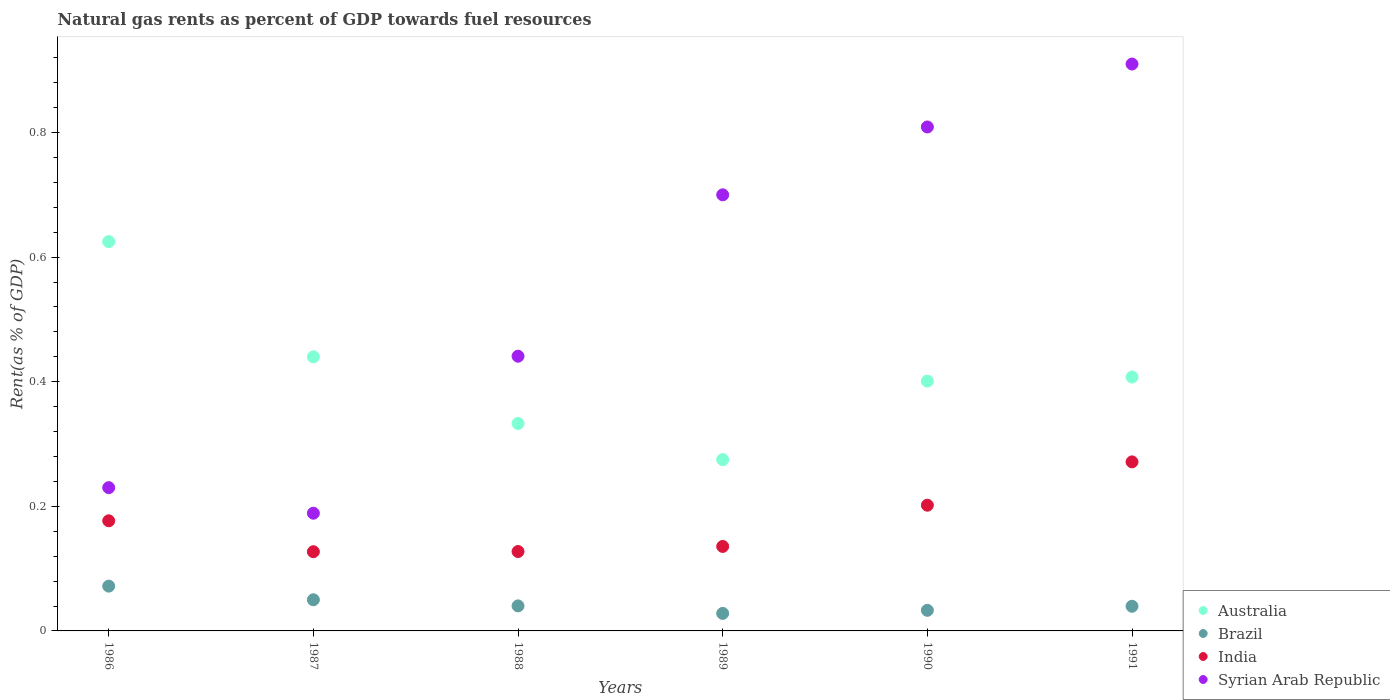Is the number of dotlines equal to the number of legend labels?
Make the answer very short. Yes. What is the matural gas rent in Syrian Arab Republic in 1990?
Your answer should be compact. 0.81. Across all years, what is the maximum matural gas rent in India?
Make the answer very short. 0.27. Across all years, what is the minimum matural gas rent in Brazil?
Your response must be concise. 0.03. In which year was the matural gas rent in Syrian Arab Republic maximum?
Your answer should be compact. 1991. In which year was the matural gas rent in Syrian Arab Republic minimum?
Ensure brevity in your answer.  1987. What is the total matural gas rent in Australia in the graph?
Offer a terse response. 2.48. What is the difference between the matural gas rent in Syrian Arab Republic in 1987 and that in 1990?
Make the answer very short. -0.62. What is the difference between the matural gas rent in Australia in 1989 and the matural gas rent in Brazil in 1986?
Offer a terse response. 0.2. What is the average matural gas rent in Brazil per year?
Offer a terse response. 0.04. In the year 1986, what is the difference between the matural gas rent in India and matural gas rent in Brazil?
Provide a succinct answer. 0.1. In how many years, is the matural gas rent in Brazil greater than 0.04 %?
Provide a short and direct response. 3. What is the ratio of the matural gas rent in Australia in 1986 to that in 1987?
Your answer should be compact. 1.42. Is the difference between the matural gas rent in India in 1987 and 1988 greater than the difference between the matural gas rent in Brazil in 1987 and 1988?
Keep it short and to the point. No. What is the difference between the highest and the second highest matural gas rent in India?
Offer a very short reply. 0.07. What is the difference between the highest and the lowest matural gas rent in Syrian Arab Republic?
Make the answer very short. 0.72. In how many years, is the matural gas rent in India greater than the average matural gas rent in India taken over all years?
Your answer should be compact. 3. How many dotlines are there?
Ensure brevity in your answer.  4. What is the difference between two consecutive major ticks on the Y-axis?
Offer a terse response. 0.2. Does the graph contain any zero values?
Your answer should be very brief. No. What is the title of the graph?
Your answer should be very brief. Natural gas rents as percent of GDP towards fuel resources. Does "Tuvalu" appear as one of the legend labels in the graph?
Make the answer very short. No. What is the label or title of the X-axis?
Your answer should be compact. Years. What is the label or title of the Y-axis?
Your answer should be very brief. Rent(as % of GDP). What is the Rent(as % of GDP) in Australia in 1986?
Your answer should be very brief. 0.62. What is the Rent(as % of GDP) of Brazil in 1986?
Offer a very short reply. 0.07. What is the Rent(as % of GDP) of India in 1986?
Your answer should be compact. 0.18. What is the Rent(as % of GDP) in Syrian Arab Republic in 1986?
Provide a succinct answer. 0.23. What is the Rent(as % of GDP) in Australia in 1987?
Ensure brevity in your answer.  0.44. What is the Rent(as % of GDP) of Brazil in 1987?
Make the answer very short. 0.05. What is the Rent(as % of GDP) of India in 1987?
Your response must be concise. 0.13. What is the Rent(as % of GDP) of Syrian Arab Republic in 1987?
Provide a short and direct response. 0.19. What is the Rent(as % of GDP) of Australia in 1988?
Provide a succinct answer. 0.33. What is the Rent(as % of GDP) of Brazil in 1988?
Offer a very short reply. 0.04. What is the Rent(as % of GDP) of India in 1988?
Ensure brevity in your answer.  0.13. What is the Rent(as % of GDP) of Syrian Arab Republic in 1988?
Offer a very short reply. 0.44. What is the Rent(as % of GDP) in Australia in 1989?
Provide a short and direct response. 0.27. What is the Rent(as % of GDP) in Brazil in 1989?
Your response must be concise. 0.03. What is the Rent(as % of GDP) of India in 1989?
Keep it short and to the point. 0.14. What is the Rent(as % of GDP) in Syrian Arab Republic in 1989?
Your answer should be very brief. 0.7. What is the Rent(as % of GDP) of Australia in 1990?
Offer a very short reply. 0.4. What is the Rent(as % of GDP) of Brazil in 1990?
Keep it short and to the point. 0.03. What is the Rent(as % of GDP) in India in 1990?
Keep it short and to the point. 0.2. What is the Rent(as % of GDP) in Syrian Arab Republic in 1990?
Give a very brief answer. 0.81. What is the Rent(as % of GDP) of Australia in 1991?
Offer a very short reply. 0.41. What is the Rent(as % of GDP) of Brazil in 1991?
Keep it short and to the point. 0.04. What is the Rent(as % of GDP) of India in 1991?
Keep it short and to the point. 0.27. What is the Rent(as % of GDP) in Syrian Arab Republic in 1991?
Offer a terse response. 0.91. Across all years, what is the maximum Rent(as % of GDP) of Australia?
Give a very brief answer. 0.62. Across all years, what is the maximum Rent(as % of GDP) of Brazil?
Your answer should be compact. 0.07. Across all years, what is the maximum Rent(as % of GDP) in India?
Give a very brief answer. 0.27. Across all years, what is the maximum Rent(as % of GDP) in Syrian Arab Republic?
Offer a very short reply. 0.91. Across all years, what is the minimum Rent(as % of GDP) in Australia?
Your answer should be compact. 0.27. Across all years, what is the minimum Rent(as % of GDP) in Brazil?
Give a very brief answer. 0.03. Across all years, what is the minimum Rent(as % of GDP) of India?
Your response must be concise. 0.13. Across all years, what is the minimum Rent(as % of GDP) of Syrian Arab Republic?
Your answer should be compact. 0.19. What is the total Rent(as % of GDP) in Australia in the graph?
Provide a succinct answer. 2.48. What is the total Rent(as % of GDP) in Brazil in the graph?
Provide a short and direct response. 0.26. What is the total Rent(as % of GDP) in India in the graph?
Ensure brevity in your answer.  1.04. What is the total Rent(as % of GDP) of Syrian Arab Republic in the graph?
Provide a short and direct response. 3.28. What is the difference between the Rent(as % of GDP) in Australia in 1986 and that in 1987?
Offer a very short reply. 0.18. What is the difference between the Rent(as % of GDP) in Brazil in 1986 and that in 1987?
Keep it short and to the point. 0.02. What is the difference between the Rent(as % of GDP) in India in 1986 and that in 1987?
Offer a very short reply. 0.05. What is the difference between the Rent(as % of GDP) in Syrian Arab Republic in 1986 and that in 1987?
Make the answer very short. 0.04. What is the difference between the Rent(as % of GDP) in Australia in 1986 and that in 1988?
Provide a succinct answer. 0.29. What is the difference between the Rent(as % of GDP) of Brazil in 1986 and that in 1988?
Your response must be concise. 0.03. What is the difference between the Rent(as % of GDP) in India in 1986 and that in 1988?
Provide a succinct answer. 0.05. What is the difference between the Rent(as % of GDP) in Syrian Arab Republic in 1986 and that in 1988?
Provide a succinct answer. -0.21. What is the difference between the Rent(as % of GDP) of Brazil in 1986 and that in 1989?
Give a very brief answer. 0.04. What is the difference between the Rent(as % of GDP) of India in 1986 and that in 1989?
Make the answer very short. 0.04. What is the difference between the Rent(as % of GDP) of Syrian Arab Republic in 1986 and that in 1989?
Offer a terse response. -0.47. What is the difference between the Rent(as % of GDP) of Australia in 1986 and that in 1990?
Give a very brief answer. 0.22. What is the difference between the Rent(as % of GDP) in Brazil in 1986 and that in 1990?
Offer a terse response. 0.04. What is the difference between the Rent(as % of GDP) of India in 1986 and that in 1990?
Provide a succinct answer. -0.03. What is the difference between the Rent(as % of GDP) of Syrian Arab Republic in 1986 and that in 1990?
Offer a very short reply. -0.58. What is the difference between the Rent(as % of GDP) in Australia in 1986 and that in 1991?
Provide a succinct answer. 0.22. What is the difference between the Rent(as % of GDP) of Brazil in 1986 and that in 1991?
Your response must be concise. 0.03. What is the difference between the Rent(as % of GDP) in India in 1986 and that in 1991?
Your answer should be compact. -0.09. What is the difference between the Rent(as % of GDP) of Syrian Arab Republic in 1986 and that in 1991?
Offer a terse response. -0.68. What is the difference between the Rent(as % of GDP) of Australia in 1987 and that in 1988?
Provide a succinct answer. 0.11. What is the difference between the Rent(as % of GDP) in Brazil in 1987 and that in 1988?
Make the answer very short. 0.01. What is the difference between the Rent(as % of GDP) of India in 1987 and that in 1988?
Provide a short and direct response. -0. What is the difference between the Rent(as % of GDP) in Syrian Arab Republic in 1987 and that in 1988?
Give a very brief answer. -0.25. What is the difference between the Rent(as % of GDP) in Australia in 1987 and that in 1989?
Your answer should be very brief. 0.17. What is the difference between the Rent(as % of GDP) of Brazil in 1987 and that in 1989?
Offer a very short reply. 0.02. What is the difference between the Rent(as % of GDP) in India in 1987 and that in 1989?
Keep it short and to the point. -0.01. What is the difference between the Rent(as % of GDP) of Syrian Arab Republic in 1987 and that in 1989?
Provide a succinct answer. -0.51. What is the difference between the Rent(as % of GDP) of Australia in 1987 and that in 1990?
Your answer should be very brief. 0.04. What is the difference between the Rent(as % of GDP) of Brazil in 1987 and that in 1990?
Offer a very short reply. 0.02. What is the difference between the Rent(as % of GDP) of India in 1987 and that in 1990?
Your answer should be compact. -0.07. What is the difference between the Rent(as % of GDP) in Syrian Arab Republic in 1987 and that in 1990?
Offer a very short reply. -0.62. What is the difference between the Rent(as % of GDP) in Australia in 1987 and that in 1991?
Your answer should be very brief. 0.03. What is the difference between the Rent(as % of GDP) in Brazil in 1987 and that in 1991?
Ensure brevity in your answer.  0.01. What is the difference between the Rent(as % of GDP) in India in 1987 and that in 1991?
Ensure brevity in your answer.  -0.14. What is the difference between the Rent(as % of GDP) in Syrian Arab Republic in 1987 and that in 1991?
Offer a very short reply. -0.72. What is the difference between the Rent(as % of GDP) in Australia in 1988 and that in 1989?
Make the answer very short. 0.06. What is the difference between the Rent(as % of GDP) of Brazil in 1988 and that in 1989?
Your answer should be compact. 0.01. What is the difference between the Rent(as % of GDP) in India in 1988 and that in 1989?
Ensure brevity in your answer.  -0.01. What is the difference between the Rent(as % of GDP) of Syrian Arab Republic in 1988 and that in 1989?
Your response must be concise. -0.26. What is the difference between the Rent(as % of GDP) in Australia in 1988 and that in 1990?
Ensure brevity in your answer.  -0.07. What is the difference between the Rent(as % of GDP) in Brazil in 1988 and that in 1990?
Offer a very short reply. 0.01. What is the difference between the Rent(as % of GDP) in India in 1988 and that in 1990?
Give a very brief answer. -0.07. What is the difference between the Rent(as % of GDP) in Syrian Arab Republic in 1988 and that in 1990?
Make the answer very short. -0.37. What is the difference between the Rent(as % of GDP) of Australia in 1988 and that in 1991?
Keep it short and to the point. -0.07. What is the difference between the Rent(as % of GDP) in Brazil in 1988 and that in 1991?
Offer a terse response. 0. What is the difference between the Rent(as % of GDP) in India in 1988 and that in 1991?
Offer a very short reply. -0.14. What is the difference between the Rent(as % of GDP) of Syrian Arab Republic in 1988 and that in 1991?
Offer a terse response. -0.47. What is the difference between the Rent(as % of GDP) of Australia in 1989 and that in 1990?
Keep it short and to the point. -0.13. What is the difference between the Rent(as % of GDP) in Brazil in 1989 and that in 1990?
Your answer should be compact. -0.01. What is the difference between the Rent(as % of GDP) in India in 1989 and that in 1990?
Ensure brevity in your answer.  -0.07. What is the difference between the Rent(as % of GDP) of Syrian Arab Republic in 1989 and that in 1990?
Keep it short and to the point. -0.11. What is the difference between the Rent(as % of GDP) of Australia in 1989 and that in 1991?
Make the answer very short. -0.13. What is the difference between the Rent(as % of GDP) in Brazil in 1989 and that in 1991?
Make the answer very short. -0.01. What is the difference between the Rent(as % of GDP) of India in 1989 and that in 1991?
Provide a short and direct response. -0.14. What is the difference between the Rent(as % of GDP) of Syrian Arab Republic in 1989 and that in 1991?
Offer a terse response. -0.21. What is the difference between the Rent(as % of GDP) in Australia in 1990 and that in 1991?
Make the answer very short. -0.01. What is the difference between the Rent(as % of GDP) of Brazil in 1990 and that in 1991?
Your response must be concise. -0.01. What is the difference between the Rent(as % of GDP) in India in 1990 and that in 1991?
Your answer should be very brief. -0.07. What is the difference between the Rent(as % of GDP) of Syrian Arab Republic in 1990 and that in 1991?
Give a very brief answer. -0.1. What is the difference between the Rent(as % of GDP) of Australia in 1986 and the Rent(as % of GDP) of Brazil in 1987?
Your answer should be compact. 0.57. What is the difference between the Rent(as % of GDP) in Australia in 1986 and the Rent(as % of GDP) in India in 1987?
Keep it short and to the point. 0.5. What is the difference between the Rent(as % of GDP) of Australia in 1986 and the Rent(as % of GDP) of Syrian Arab Republic in 1987?
Your response must be concise. 0.44. What is the difference between the Rent(as % of GDP) in Brazil in 1986 and the Rent(as % of GDP) in India in 1987?
Your answer should be very brief. -0.06. What is the difference between the Rent(as % of GDP) in Brazil in 1986 and the Rent(as % of GDP) in Syrian Arab Republic in 1987?
Your answer should be compact. -0.12. What is the difference between the Rent(as % of GDP) in India in 1986 and the Rent(as % of GDP) in Syrian Arab Republic in 1987?
Make the answer very short. -0.01. What is the difference between the Rent(as % of GDP) of Australia in 1986 and the Rent(as % of GDP) of Brazil in 1988?
Offer a terse response. 0.58. What is the difference between the Rent(as % of GDP) in Australia in 1986 and the Rent(as % of GDP) in India in 1988?
Keep it short and to the point. 0.5. What is the difference between the Rent(as % of GDP) in Australia in 1986 and the Rent(as % of GDP) in Syrian Arab Republic in 1988?
Your answer should be very brief. 0.18. What is the difference between the Rent(as % of GDP) in Brazil in 1986 and the Rent(as % of GDP) in India in 1988?
Provide a succinct answer. -0.06. What is the difference between the Rent(as % of GDP) of Brazil in 1986 and the Rent(as % of GDP) of Syrian Arab Republic in 1988?
Provide a short and direct response. -0.37. What is the difference between the Rent(as % of GDP) of India in 1986 and the Rent(as % of GDP) of Syrian Arab Republic in 1988?
Your answer should be compact. -0.26. What is the difference between the Rent(as % of GDP) of Australia in 1986 and the Rent(as % of GDP) of Brazil in 1989?
Provide a short and direct response. 0.6. What is the difference between the Rent(as % of GDP) in Australia in 1986 and the Rent(as % of GDP) in India in 1989?
Ensure brevity in your answer.  0.49. What is the difference between the Rent(as % of GDP) in Australia in 1986 and the Rent(as % of GDP) in Syrian Arab Republic in 1989?
Your answer should be very brief. -0.08. What is the difference between the Rent(as % of GDP) of Brazil in 1986 and the Rent(as % of GDP) of India in 1989?
Offer a very short reply. -0.06. What is the difference between the Rent(as % of GDP) in Brazil in 1986 and the Rent(as % of GDP) in Syrian Arab Republic in 1989?
Offer a very short reply. -0.63. What is the difference between the Rent(as % of GDP) in India in 1986 and the Rent(as % of GDP) in Syrian Arab Republic in 1989?
Your answer should be compact. -0.52. What is the difference between the Rent(as % of GDP) in Australia in 1986 and the Rent(as % of GDP) in Brazil in 1990?
Offer a terse response. 0.59. What is the difference between the Rent(as % of GDP) of Australia in 1986 and the Rent(as % of GDP) of India in 1990?
Keep it short and to the point. 0.42. What is the difference between the Rent(as % of GDP) in Australia in 1986 and the Rent(as % of GDP) in Syrian Arab Republic in 1990?
Ensure brevity in your answer.  -0.18. What is the difference between the Rent(as % of GDP) of Brazil in 1986 and the Rent(as % of GDP) of India in 1990?
Provide a succinct answer. -0.13. What is the difference between the Rent(as % of GDP) of Brazil in 1986 and the Rent(as % of GDP) of Syrian Arab Republic in 1990?
Make the answer very short. -0.74. What is the difference between the Rent(as % of GDP) in India in 1986 and the Rent(as % of GDP) in Syrian Arab Republic in 1990?
Keep it short and to the point. -0.63. What is the difference between the Rent(as % of GDP) of Australia in 1986 and the Rent(as % of GDP) of Brazil in 1991?
Your answer should be compact. 0.59. What is the difference between the Rent(as % of GDP) of Australia in 1986 and the Rent(as % of GDP) of India in 1991?
Your response must be concise. 0.35. What is the difference between the Rent(as % of GDP) in Australia in 1986 and the Rent(as % of GDP) in Syrian Arab Republic in 1991?
Offer a terse response. -0.28. What is the difference between the Rent(as % of GDP) in Brazil in 1986 and the Rent(as % of GDP) in India in 1991?
Offer a very short reply. -0.2. What is the difference between the Rent(as % of GDP) of Brazil in 1986 and the Rent(as % of GDP) of Syrian Arab Republic in 1991?
Offer a terse response. -0.84. What is the difference between the Rent(as % of GDP) of India in 1986 and the Rent(as % of GDP) of Syrian Arab Republic in 1991?
Provide a succinct answer. -0.73. What is the difference between the Rent(as % of GDP) of Australia in 1987 and the Rent(as % of GDP) of Brazil in 1988?
Ensure brevity in your answer.  0.4. What is the difference between the Rent(as % of GDP) in Australia in 1987 and the Rent(as % of GDP) in India in 1988?
Offer a very short reply. 0.31. What is the difference between the Rent(as % of GDP) in Australia in 1987 and the Rent(as % of GDP) in Syrian Arab Republic in 1988?
Ensure brevity in your answer.  -0. What is the difference between the Rent(as % of GDP) of Brazil in 1987 and the Rent(as % of GDP) of India in 1988?
Your answer should be compact. -0.08. What is the difference between the Rent(as % of GDP) of Brazil in 1987 and the Rent(as % of GDP) of Syrian Arab Republic in 1988?
Give a very brief answer. -0.39. What is the difference between the Rent(as % of GDP) in India in 1987 and the Rent(as % of GDP) in Syrian Arab Republic in 1988?
Ensure brevity in your answer.  -0.31. What is the difference between the Rent(as % of GDP) in Australia in 1987 and the Rent(as % of GDP) in Brazil in 1989?
Your response must be concise. 0.41. What is the difference between the Rent(as % of GDP) of Australia in 1987 and the Rent(as % of GDP) of India in 1989?
Offer a terse response. 0.3. What is the difference between the Rent(as % of GDP) in Australia in 1987 and the Rent(as % of GDP) in Syrian Arab Republic in 1989?
Your answer should be compact. -0.26. What is the difference between the Rent(as % of GDP) in Brazil in 1987 and the Rent(as % of GDP) in India in 1989?
Your answer should be compact. -0.09. What is the difference between the Rent(as % of GDP) in Brazil in 1987 and the Rent(as % of GDP) in Syrian Arab Republic in 1989?
Offer a terse response. -0.65. What is the difference between the Rent(as % of GDP) of India in 1987 and the Rent(as % of GDP) of Syrian Arab Republic in 1989?
Your answer should be compact. -0.57. What is the difference between the Rent(as % of GDP) in Australia in 1987 and the Rent(as % of GDP) in Brazil in 1990?
Provide a succinct answer. 0.41. What is the difference between the Rent(as % of GDP) of Australia in 1987 and the Rent(as % of GDP) of India in 1990?
Keep it short and to the point. 0.24. What is the difference between the Rent(as % of GDP) in Australia in 1987 and the Rent(as % of GDP) in Syrian Arab Republic in 1990?
Keep it short and to the point. -0.37. What is the difference between the Rent(as % of GDP) in Brazil in 1987 and the Rent(as % of GDP) in India in 1990?
Make the answer very short. -0.15. What is the difference between the Rent(as % of GDP) in Brazil in 1987 and the Rent(as % of GDP) in Syrian Arab Republic in 1990?
Keep it short and to the point. -0.76. What is the difference between the Rent(as % of GDP) in India in 1987 and the Rent(as % of GDP) in Syrian Arab Republic in 1990?
Keep it short and to the point. -0.68. What is the difference between the Rent(as % of GDP) in Australia in 1987 and the Rent(as % of GDP) in Brazil in 1991?
Ensure brevity in your answer.  0.4. What is the difference between the Rent(as % of GDP) in Australia in 1987 and the Rent(as % of GDP) in India in 1991?
Offer a very short reply. 0.17. What is the difference between the Rent(as % of GDP) in Australia in 1987 and the Rent(as % of GDP) in Syrian Arab Republic in 1991?
Give a very brief answer. -0.47. What is the difference between the Rent(as % of GDP) of Brazil in 1987 and the Rent(as % of GDP) of India in 1991?
Offer a very short reply. -0.22. What is the difference between the Rent(as % of GDP) in Brazil in 1987 and the Rent(as % of GDP) in Syrian Arab Republic in 1991?
Provide a short and direct response. -0.86. What is the difference between the Rent(as % of GDP) in India in 1987 and the Rent(as % of GDP) in Syrian Arab Republic in 1991?
Keep it short and to the point. -0.78. What is the difference between the Rent(as % of GDP) of Australia in 1988 and the Rent(as % of GDP) of Brazil in 1989?
Your answer should be very brief. 0.3. What is the difference between the Rent(as % of GDP) in Australia in 1988 and the Rent(as % of GDP) in India in 1989?
Provide a short and direct response. 0.2. What is the difference between the Rent(as % of GDP) in Australia in 1988 and the Rent(as % of GDP) in Syrian Arab Republic in 1989?
Your answer should be very brief. -0.37. What is the difference between the Rent(as % of GDP) in Brazil in 1988 and the Rent(as % of GDP) in India in 1989?
Give a very brief answer. -0.1. What is the difference between the Rent(as % of GDP) in Brazil in 1988 and the Rent(as % of GDP) in Syrian Arab Republic in 1989?
Give a very brief answer. -0.66. What is the difference between the Rent(as % of GDP) of India in 1988 and the Rent(as % of GDP) of Syrian Arab Republic in 1989?
Make the answer very short. -0.57. What is the difference between the Rent(as % of GDP) in Australia in 1988 and the Rent(as % of GDP) in Brazil in 1990?
Offer a terse response. 0.3. What is the difference between the Rent(as % of GDP) of Australia in 1988 and the Rent(as % of GDP) of India in 1990?
Your response must be concise. 0.13. What is the difference between the Rent(as % of GDP) in Australia in 1988 and the Rent(as % of GDP) in Syrian Arab Republic in 1990?
Offer a very short reply. -0.48. What is the difference between the Rent(as % of GDP) of Brazil in 1988 and the Rent(as % of GDP) of India in 1990?
Provide a succinct answer. -0.16. What is the difference between the Rent(as % of GDP) of Brazil in 1988 and the Rent(as % of GDP) of Syrian Arab Republic in 1990?
Offer a terse response. -0.77. What is the difference between the Rent(as % of GDP) of India in 1988 and the Rent(as % of GDP) of Syrian Arab Republic in 1990?
Offer a very short reply. -0.68. What is the difference between the Rent(as % of GDP) of Australia in 1988 and the Rent(as % of GDP) of Brazil in 1991?
Your response must be concise. 0.29. What is the difference between the Rent(as % of GDP) in Australia in 1988 and the Rent(as % of GDP) in India in 1991?
Ensure brevity in your answer.  0.06. What is the difference between the Rent(as % of GDP) of Australia in 1988 and the Rent(as % of GDP) of Syrian Arab Republic in 1991?
Your answer should be very brief. -0.58. What is the difference between the Rent(as % of GDP) of Brazil in 1988 and the Rent(as % of GDP) of India in 1991?
Your answer should be very brief. -0.23. What is the difference between the Rent(as % of GDP) of Brazil in 1988 and the Rent(as % of GDP) of Syrian Arab Republic in 1991?
Your answer should be very brief. -0.87. What is the difference between the Rent(as % of GDP) in India in 1988 and the Rent(as % of GDP) in Syrian Arab Republic in 1991?
Your answer should be very brief. -0.78. What is the difference between the Rent(as % of GDP) in Australia in 1989 and the Rent(as % of GDP) in Brazil in 1990?
Offer a terse response. 0.24. What is the difference between the Rent(as % of GDP) of Australia in 1989 and the Rent(as % of GDP) of India in 1990?
Your answer should be very brief. 0.07. What is the difference between the Rent(as % of GDP) of Australia in 1989 and the Rent(as % of GDP) of Syrian Arab Republic in 1990?
Your answer should be very brief. -0.53. What is the difference between the Rent(as % of GDP) of Brazil in 1989 and the Rent(as % of GDP) of India in 1990?
Offer a very short reply. -0.17. What is the difference between the Rent(as % of GDP) in Brazil in 1989 and the Rent(as % of GDP) in Syrian Arab Republic in 1990?
Provide a short and direct response. -0.78. What is the difference between the Rent(as % of GDP) of India in 1989 and the Rent(as % of GDP) of Syrian Arab Republic in 1990?
Provide a short and direct response. -0.67. What is the difference between the Rent(as % of GDP) in Australia in 1989 and the Rent(as % of GDP) in Brazil in 1991?
Your answer should be compact. 0.24. What is the difference between the Rent(as % of GDP) of Australia in 1989 and the Rent(as % of GDP) of India in 1991?
Your answer should be very brief. 0. What is the difference between the Rent(as % of GDP) of Australia in 1989 and the Rent(as % of GDP) of Syrian Arab Republic in 1991?
Your answer should be compact. -0.64. What is the difference between the Rent(as % of GDP) of Brazil in 1989 and the Rent(as % of GDP) of India in 1991?
Keep it short and to the point. -0.24. What is the difference between the Rent(as % of GDP) of Brazil in 1989 and the Rent(as % of GDP) of Syrian Arab Republic in 1991?
Provide a short and direct response. -0.88. What is the difference between the Rent(as % of GDP) in India in 1989 and the Rent(as % of GDP) in Syrian Arab Republic in 1991?
Provide a succinct answer. -0.77. What is the difference between the Rent(as % of GDP) of Australia in 1990 and the Rent(as % of GDP) of Brazil in 1991?
Keep it short and to the point. 0.36. What is the difference between the Rent(as % of GDP) in Australia in 1990 and the Rent(as % of GDP) in India in 1991?
Ensure brevity in your answer.  0.13. What is the difference between the Rent(as % of GDP) of Australia in 1990 and the Rent(as % of GDP) of Syrian Arab Republic in 1991?
Make the answer very short. -0.51. What is the difference between the Rent(as % of GDP) in Brazil in 1990 and the Rent(as % of GDP) in India in 1991?
Give a very brief answer. -0.24. What is the difference between the Rent(as % of GDP) of Brazil in 1990 and the Rent(as % of GDP) of Syrian Arab Republic in 1991?
Your answer should be very brief. -0.88. What is the difference between the Rent(as % of GDP) in India in 1990 and the Rent(as % of GDP) in Syrian Arab Republic in 1991?
Your answer should be compact. -0.71. What is the average Rent(as % of GDP) in Australia per year?
Make the answer very short. 0.41. What is the average Rent(as % of GDP) of Brazil per year?
Your response must be concise. 0.04. What is the average Rent(as % of GDP) in India per year?
Provide a succinct answer. 0.17. What is the average Rent(as % of GDP) in Syrian Arab Republic per year?
Your response must be concise. 0.55. In the year 1986, what is the difference between the Rent(as % of GDP) in Australia and Rent(as % of GDP) in Brazil?
Your response must be concise. 0.55. In the year 1986, what is the difference between the Rent(as % of GDP) in Australia and Rent(as % of GDP) in India?
Your response must be concise. 0.45. In the year 1986, what is the difference between the Rent(as % of GDP) of Australia and Rent(as % of GDP) of Syrian Arab Republic?
Your answer should be very brief. 0.39. In the year 1986, what is the difference between the Rent(as % of GDP) of Brazil and Rent(as % of GDP) of India?
Your answer should be very brief. -0.1. In the year 1986, what is the difference between the Rent(as % of GDP) in Brazil and Rent(as % of GDP) in Syrian Arab Republic?
Offer a very short reply. -0.16. In the year 1986, what is the difference between the Rent(as % of GDP) of India and Rent(as % of GDP) of Syrian Arab Republic?
Make the answer very short. -0.05. In the year 1987, what is the difference between the Rent(as % of GDP) in Australia and Rent(as % of GDP) in Brazil?
Your response must be concise. 0.39. In the year 1987, what is the difference between the Rent(as % of GDP) in Australia and Rent(as % of GDP) in India?
Make the answer very short. 0.31. In the year 1987, what is the difference between the Rent(as % of GDP) of Australia and Rent(as % of GDP) of Syrian Arab Republic?
Ensure brevity in your answer.  0.25. In the year 1987, what is the difference between the Rent(as % of GDP) in Brazil and Rent(as % of GDP) in India?
Your response must be concise. -0.08. In the year 1987, what is the difference between the Rent(as % of GDP) in Brazil and Rent(as % of GDP) in Syrian Arab Republic?
Your response must be concise. -0.14. In the year 1987, what is the difference between the Rent(as % of GDP) of India and Rent(as % of GDP) of Syrian Arab Republic?
Your answer should be very brief. -0.06. In the year 1988, what is the difference between the Rent(as % of GDP) of Australia and Rent(as % of GDP) of Brazil?
Make the answer very short. 0.29. In the year 1988, what is the difference between the Rent(as % of GDP) in Australia and Rent(as % of GDP) in India?
Provide a succinct answer. 0.21. In the year 1988, what is the difference between the Rent(as % of GDP) in Australia and Rent(as % of GDP) in Syrian Arab Republic?
Provide a succinct answer. -0.11. In the year 1988, what is the difference between the Rent(as % of GDP) of Brazil and Rent(as % of GDP) of India?
Your answer should be compact. -0.09. In the year 1988, what is the difference between the Rent(as % of GDP) of Brazil and Rent(as % of GDP) of Syrian Arab Republic?
Offer a very short reply. -0.4. In the year 1988, what is the difference between the Rent(as % of GDP) of India and Rent(as % of GDP) of Syrian Arab Republic?
Your answer should be compact. -0.31. In the year 1989, what is the difference between the Rent(as % of GDP) of Australia and Rent(as % of GDP) of Brazil?
Give a very brief answer. 0.25. In the year 1989, what is the difference between the Rent(as % of GDP) in Australia and Rent(as % of GDP) in India?
Your answer should be very brief. 0.14. In the year 1989, what is the difference between the Rent(as % of GDP) of Australia and Rent(as % of GDP) of Syrian Arab Republic?
Offer a terse response. -0.43. In the year 1989, what is the difference between the Rent(as % of GDP) of Brazil and Rent(as % of GDP) of India?
Provide a succinct answer. -0.11. In the year 1989, what is the difference between the Rent(as % of GDP) of Brazil and Rent(as % of GDP) of Syrian Arab Republic?
Offer a terse response. -0.67. In the year 1989, what is the difference between the Rent(as % of GDP) of India and Rent(as % of GDP) of Syrian Arab Republic?
Offer a very short reply. -0.56. In the year 1990, what is the difference between the Rent(as % of GDP) in Australia and Rent(as % of GDP) in Brazil?
Your response must be concise. 0.37. In the year 1990, what is the difference between the Rent(as % of GDP) in Australia and Rent(as % of GDP) in India?
Your response must be concise. 0.2. In the year 1990, what is the difference between the Rent(as % of GDP) of Australia and Rent(as % of GDP) of Syrian Arab Republic?
Give a very brief answer. -0.41. In the year 1990, what is the difference between the Rent(as % of GDP) in Brazil and Rent(as % of GDP) in India?
Give a very brief answer. -0.17. In the year 1990, what is the difference between the Rent(as % of GDP) in Brazil and Rent(as % of GDP) in Syrian Arab Republic?
Your response must be concise. -0.78. In the year 1990, what is the difference between the Rent(as % of GDP) of India and Rent(as % of GDP) of Syrian Arab Republic?
Your answer should be compact. -0.61. In the year 1991, what is the difference between the Rent(as % of GDP) of Australia and Rent(as % of GDP) of Brazil?
Your response must be concise. 0.37. In the year 1991, what is the difference between the Rent(as % of GDP) of Australia and Rent(as % of GDP) of India?
Make the answer very short. 0.14. In the year 1991, what is the difference between the Rent(as % of GDP) in Australia and Rent(as % of GDP) in Syrian Arab Republic?
Keep it short and to the point. -0.5. In the year 1991, what is the difference between the Rent(as % of GDP) of Brazil and Rent(as % of GDP) of India?
Keep it short and to the point. -0.23. In the year 1991, what is the difference between the Rent(as % of GDP) of Brazil and Rent(as % of GDP) of Syrian Arab Republic?
Your response must be concise. -0.87. In the year 1991, what is the difference between the Rent(as % of GDP) of India and Rent(as % of GDP) of Syrian Arab Republic?
Offer a very short reply. -0.64. What is the ratio of the Rent(as % of GDP) of Australia in 1986 to that in 1987?
Provide a succinct answer. 1.42. What is the ratio of the Rent(as % of GDP) in Brazil in 1986 to that in 1987?
Offer a very short reply. 1.44. What is the ratio of the Rent(as % of GDP) in India in 1986 to that in 1987?
Your answer should be very brief. 1.39. What is the ratio of the Rent(as % of GDP) of Syrian Arab Republic in 1986 to that in 1987?
Keep it short and to the point. 1.22. What is the ratio of the Rent(as % of GDP) of Australia in 1986 to that in 1988?
Offer a terse response. 1.88. What is the ratio of the Rent(as % of GDP) of Brazil in 1986 to that in 1988?
Provide a succinct answer. 1.79. What is the ratio of the Rent(as % of GDP) of India in 1986 to that in 1988?
Your answer should be compact. 1.39. What is the ratio of the Rent(as % of GDP) in Syrian Arab Republic in 1986 to that in 1988?
Make the answer very short. 0.52. What is the ratio of the Rent(as % of GDP) in Australia in 1986 to that in 1989?
Ensure brevity in your answer.  2.27. What is the ratio of the Rent(as % of GDP) in Brazil in 1986 to that in 1989?
Give a very brief answer. 2.56. What is the ratio of the Rent(as % of GDP) of India in 1986 to that in 1989?
Keep it short and to the point. 1.3. What is the ratio of the Rent(as % of GDP) of Syrian Arab Republic in 1986 to that in 1989?
Your answer should be compact. 0.33. What is the ratio of the Rent(as % of GDP) of Australia in 1986 to that in 1990?
Ensure brevity in your answer.  1.56. What is the ratio of the Rent(as % of GDP) in Brazil in 1986 to that in 1990?
Provide a short and direct response. 2.17. What is the ratio of the Rent(as % of GDP) of India in 1986 to that in 1990?
Offer a terse response. 0.88. What is the ratio of the Rent(as % of GDP) of Syrian Arab Republic in 1986 to that in 1990?
Your answer should be compact. 0.28. What is the ratio of the Rent(as % of GDP) of Australia in 1986 to that in 1991?
Keep it short and to the point. 1.53. What is the ratio of the Rent(as % of GDP) of Brazil in 1986 to that in 1991?
Your answer should be very brief. 1.82. What is the ratio of the Rent(as % of GDP) of India in 1986 to that in 1991?
Make the answer very short. 0.65. What is the ratio of the Rent(as % of GDP) in Syrian Arab Republic in 1986 to that in 1991?
Provide a succinct answer. 0.25. What is the ratio of the Rent(as % of GDP) in Australia in 1987 to that in 1988?
Ensure brevity in your answer.  1.32. What is the ratio of the Rent(as % of GDP) of Brazil in 1987 to that in 1988?
Provide a succinct answer. 1.24. What is the ratio of the Rent(as % of GDP) in India in 1987 to that in 1988?
Keep it short and to the point. 1. What is the ratio of the Rent(as % of GDP) of Syrian Arab Republic in 1987 to that in 1988?
Ensure brevity in your answer.  0.43. What is the ratio of the Rent(as % of GDP) of Australia in 1987 to that in 1989?
Keep it short and to the point. 1.6. What is the ratio of the Rent(as % of GDP) in Brazil in 1987 to that in 1989?
Make the answer very short. 1.78. What is the ratio of the Rent(as % of GDP) in India in 1987 to that in 1989?
Provide a short and direct response. 0.94. What is the ratio of the Rent(as % of GDP) in Syrian Arab Republic in 1987 to that in 1989?
Keep it short and to the point. 0.27. What is the ratio of the Rent(as % of GDP) of Australia in 1987 to that in 1990?
Make the answer very short. 1.1. What is the ratio of the Rent(as % of GDP) in Brazil in 1987 to that in 1990?
Your answer should be compact. 1.51. What is the ratio of the Rent(as % of GDP) in India in 1987 to that in 1990?
Offer a terse response. 0.63. What is the ratio of the Rent(as % of GDP) of Syrian Arab Republic in 1987 to that in 1990?
Your response must be concise. 0.23. What is the ratio of the Rent(as % of GDP) in Australia in 1987 to that in 1991?
Ensure brevity in your answer.  1.08. What is the ratio of the Rent(as % of GDP) in Brazil in 1987 to that in 1991?
Keep it short and to the point. 1.26. What is the ratio of the Rent(as % of GDP) in India in 1987 to that in 1991?
Your answer should be compact. 0.47. What is the ratio of the Rent(as % of GDP) in Syrian Arab Republic in 1987 to that in 1991?
Make the answer very short. 0.21. What is the ratio of the Rent(as % of GDP) of Australia in 1988 to that in 1989?
Your response must be concise. 1.21. What is the ratio of the Rent(as % of GDP) in Brazil in 1988 to that in 1989?
Ensure brevity in your answer.  1.43. What is the ratio of the Rent(as % of GDP) in India in 1988 to that in 1989?
Ensure brevity in your answer.  0.94. What is the ratio of the Rent(as % of GDP) in Syrian Arab Republic in 1988 to that in 1989?
Your answer should be very brief. 0.63. What is the ratio of the Rent(as % of GDP) in Australia in 1988 to that in 1990?
Ensure brevity in your answer.  0.83. What is the ratio of the Rent(as % of GDP) of Brazil in 1988 to that in 1990?
Ensure brevity in your answer.  1.21. What is the ratio of the Rent(as % of GDP) of India in 1988 to that in 1990?
Give a very brief answer. 0.63. What is the ratio of the Rent(as % of GDP) in Syrian Arab Republic in 1988 to that in 1990?
Provide a short and direct response. 0.55. What is the ratio of the Rent(as % of GDP) in Australia in 1988 to that in 1991?
Ensure brevity in your answer.  0.82. What is the ratio of the Rent(as % of GDP) of India in 1988 to that in 1991?
Give a very brief answer. 0.47. What is the ratio of the Rent(as % of GDP) of Syrian Arab Republic in 1988 to that in 1991?
Make the answer very short. 0.48. What is the ratio of the Rent(as % of GDP) in Australia in 1989 to that in 1990?
Keep it short and to the point. 0.69. What is the ratio of the Rent(as % of GDP) of Brazil in 1989 to that in 1990?
Keep it short and to the point. 0.85. What is the ratio of the Rent(as % of GDP) of India in 1989 to that in 1990?
Provide a short and direct response. 0.67. What is the ratio of the Rent(as % of GDP) of Syrian Arab Republic in 1989 to that in 1990?
Your response must be concise. 0.87. What is the ratio of the Rent(as % of GDP) in Australia in 1989 to that in 1991?
Offer a terse response. 0.67. What is the ratio of the Rent(as % of GDP) in Brazil in 1989 to that in 1991?
Make the answer very short. 0.71. What is the ratio of the Rent(as % of GDP) in India in 1989 to that in 1991?
Your answer should be compact. 0.5. What is the ratio of the Rent(as % of GDP) of Syrian Arab Republic in 1989 to that in 1991?
Give a very brief answer. 0.77. What is the ratio of the Rent(as % of GDP) of Australia in 1990 to that in 1991?
Offer a very short reply. 0.98. What is the ratio of the Rent(as % of GDP) of Brazil in 1990 to that in 1991?
Provide a succinct answer. 0.84. What is the ratio of the Rent(as % of GDP) of India in 1990 to that in 1991?
Provide a succinct answer. 0.74. What is the ratio of the Rent(as % of GDP) in Syrian Arab Republic in 1990 to that in 1991?
Your answer should be very brief. 0.89. What is the difference between the highest and the second highest Rent(as % of GDP) in Australia?
Provide a short and direct response. 0.18. What is the difference between the highest and the second highest Rent(as % of GDP) in Brazil?
Offer a very short reply. 0.02. What is the difference between the highest and the second highest Rent(as % of GDP) in India?
Keep it short and to the point. 0.07. What is the difference between the highest and the second highest Rent(as % of GDP) of Syrian Arab Republic?
Ensure brevity in your answer.  0.1. What is the difference between the highest and the lowest Rent(as % of GDP) of Brazil?
Provide a short and direct response. 0.04. What is the difference between the highest and the lowest Rent(as % of GDP) in India?
Provide a short and direct response. 0.14. What is the difference between the highest and the lowest Rent(as % of GDP) in Syrian Arab Republic?
Your answer should be very brief. 0.72. 